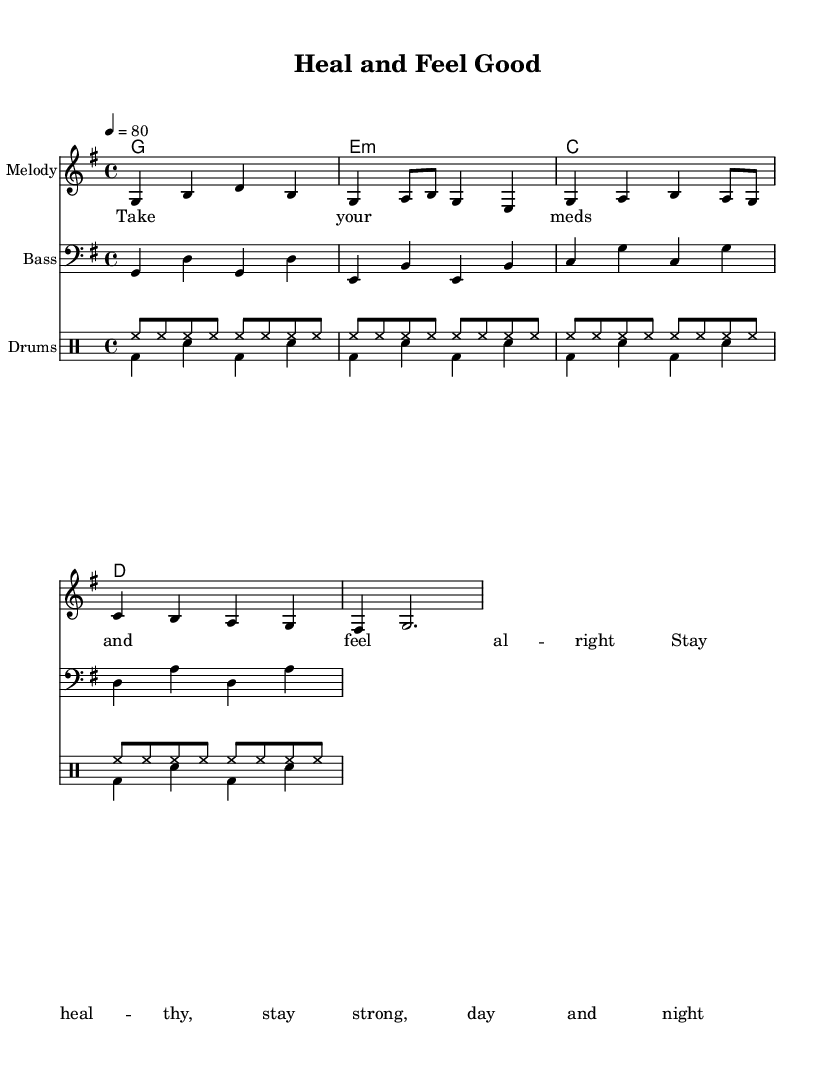What is the key signature of this music? The music is in G major, which has one sharp (F#). The key signature is indicated at the beginning with the 'g' placed in the key indication.
Answer: G major What is the time signature of this piece? The time signature is located at the beginning of the sheet music. It shows "4/4," meaning there are four beats in each measure and a quarter note receives one beat.
Answer: 4/4 What is the tempo marking for this music? The tempo marking is found at the beginning, indicated as "4 = 80." This means that the basic pulse or beat is set to 80 beats per minute.
Answer: 80 How many measures are in the melody section? To find the number of measures, count the individual groupings separated by bars in the melody section, which show there are four measures present.
Answer: 4 What is the main theme in the lyrics of this piece? The lyrics describe taking medication and promoting health and strength. This is emphasized in phrases like "Take your meds and feel alright" and "Stay healthy, stay strong."
Answer: Health and wellness What is the predominant instrument used in this reggae composition? The primary focus of this piece is the melody for a single instrument, indicated clearly with "Melody" at the top of its staff. This typically refers to instruments like guitar or keyboard, common in reggae.
Answer: Melody How is the drum pattern structured in this piece? The drums are divided into two parts: the 'up' pattern and the 'down' pattern. Each pattern contains repeated beats that create a consistent rhythm typical for reggae music.
Answer: Two parts 